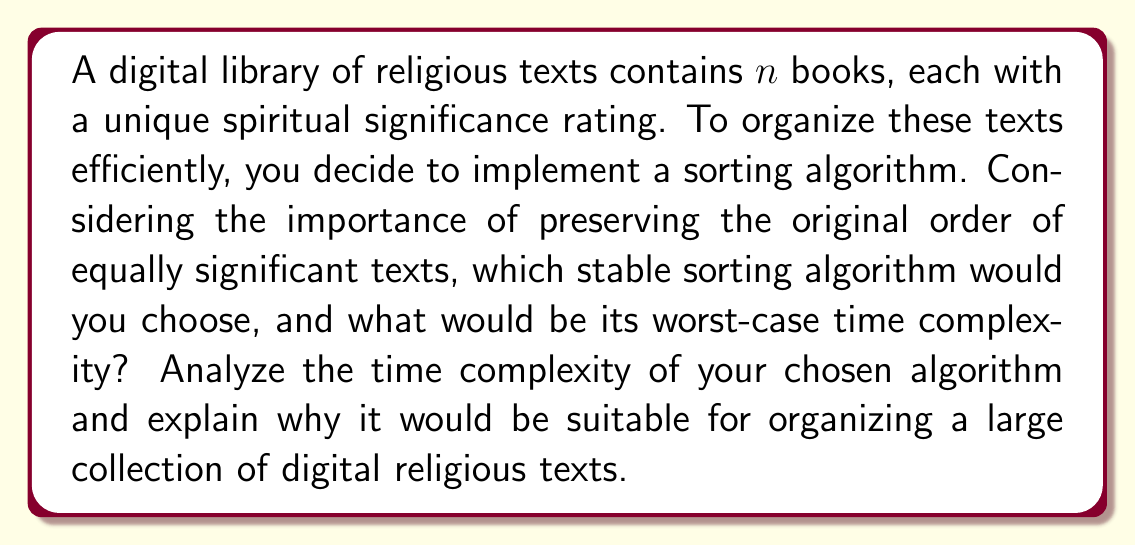Can you solve this math problem? To address this question, we need to consider stable sorting algorithms and their time complexities. A stable sort maintains the relative order of equal elements, which is important for preserving the original arrangement of texts with equal spiritual significance.

Common stable sorting algorithms include:

1. Bubble Sort: $O(n^2)$
2. Insertion Sort: $O(n^2)$
3. Merge Sort: $O(n \log n)$
4. Counting Sort: $O(n + k)$, where $k$ is the range of input

For a large collection of digital religious texts, we want an efficient algorithm that can handle a significant number of books. Among these, Merge Sort offers the best worst-case time complexity for general-purpose sorting.

Analysis of Merge Sort:
1. Divide: The algorithm recursively divides the input array into two halves until we have subarrays of size 1.
2. Conquer: Merge the subarrays back together, maintaining order.

The recurrence relation for Merge Sort is:

$$T(n) = 2T(n/2) + O(n)$$

Solving this recurrence using the Master Theorem, we get:

$$T(n) = O(n \log n)$$

Merge Sort is suitable for organizing digital religious texts because:
1. It has a consistent $O(n \log n)$ time complexity for all input sizes.
2. It's stable, preserving the original order of texts with equal significance.
3. It works well for external sorting, which is useful for large collections that don't fit in memory.

While Counting Sort can be faster for certain input distributions, it requires knowledge of the range of spiritual significance ratings and may not be as flexible for general use in a diverse religious text collection.
Answer: The chosen algorithm is Merge Sort, with a worst-case time complexity of $O(n \log n)$. 